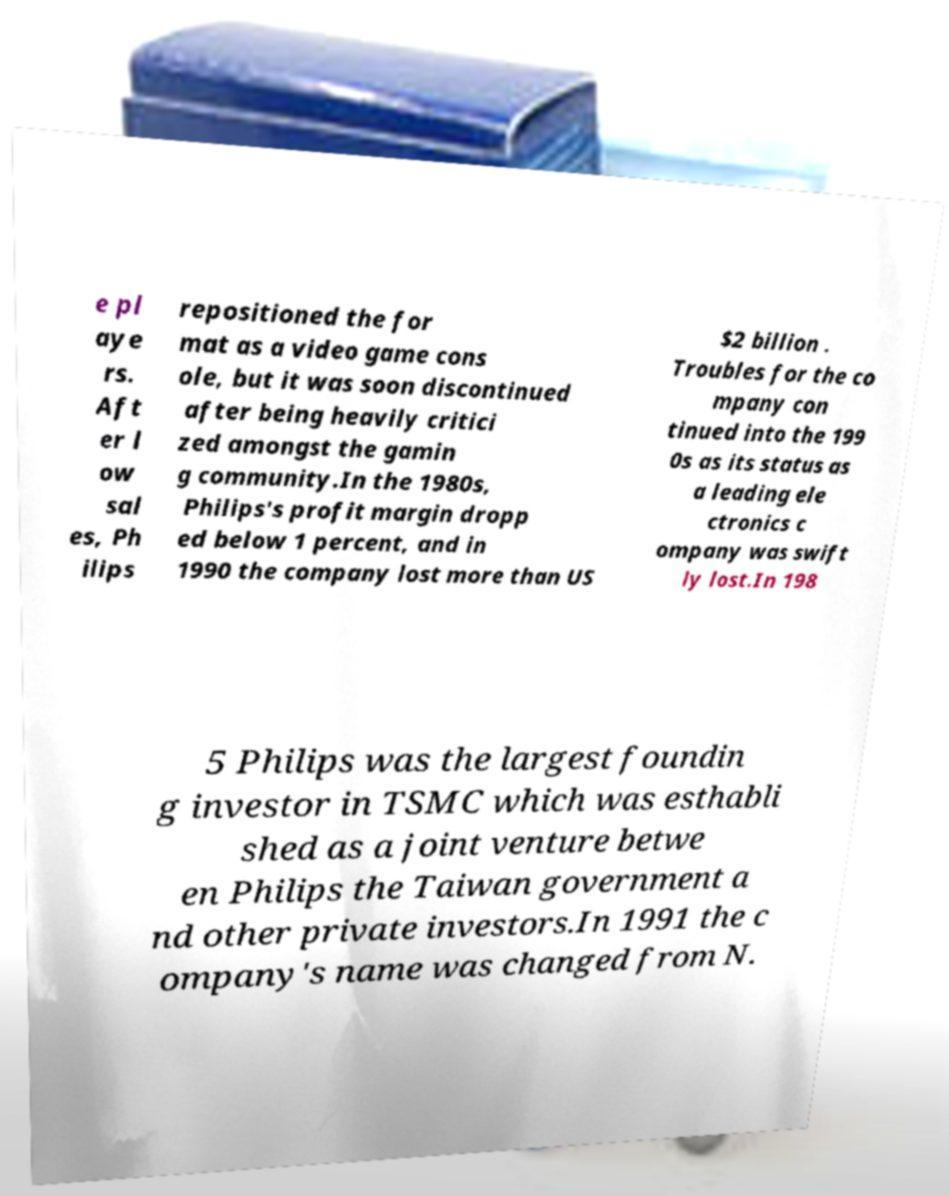What messages or text are displayed in this image? I need them in a readable, typed format. e pl aye rs. Aft er l ow sal es, Ph ilips repositioned the for mat as a video game cons ole, but it was soon discontinued after being heavily critici zed amongst the gamin g community.In the 1980s, Philips's profit margin dropp ed below 1 percent, and in 1990 the company lost more than US $2 billion . Troubles for the co mpany con tinued into the 199 0s as its status as a leading ele ctronics c ompany was swift ly lost.In 198 5 Philips was the largest foundin g investor in TSMC which was esthabli shed as a joint venture betwe en Philips the Taiwan government a nd other private investors.In 1991 the c ompany's name was changed from N. 